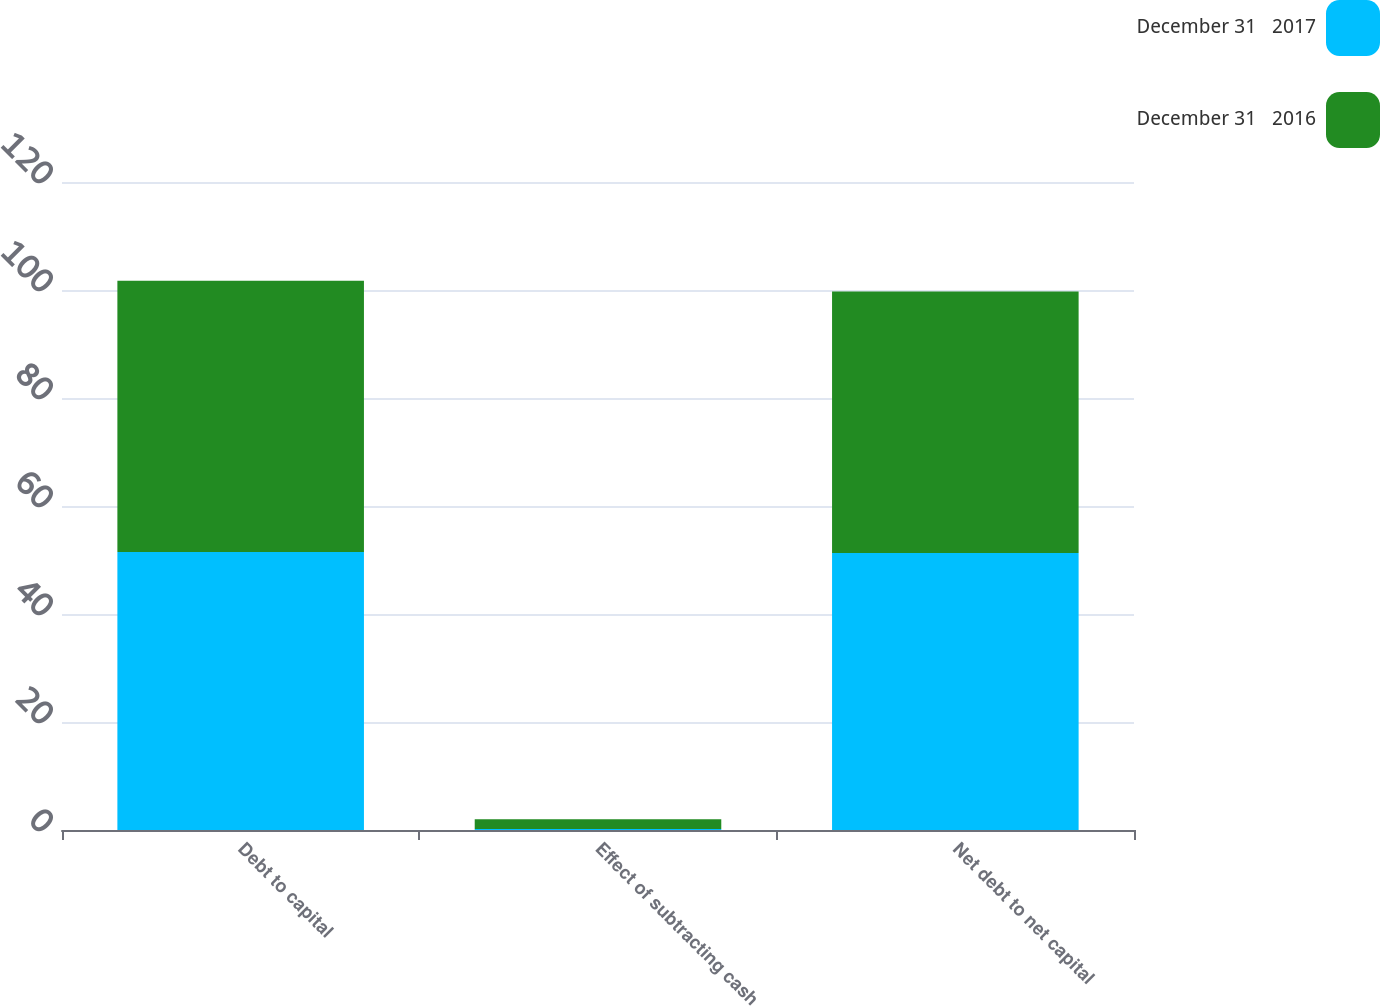<chart> <loc_0><loc_0><loc_500><loc_500><stacked_bar_chart><ecel><fcel>Debt to capital<fcel>Effect of subtracting cash<fcel>Net debt to net capital<nl><fcel>December 31   2017<fcel>51.5<fcel>0.2<fcel>51.3<nl><fcel>December 31   2016<fcel>50.2<fcel>1.8<fcel>48.4<nl></chart> 